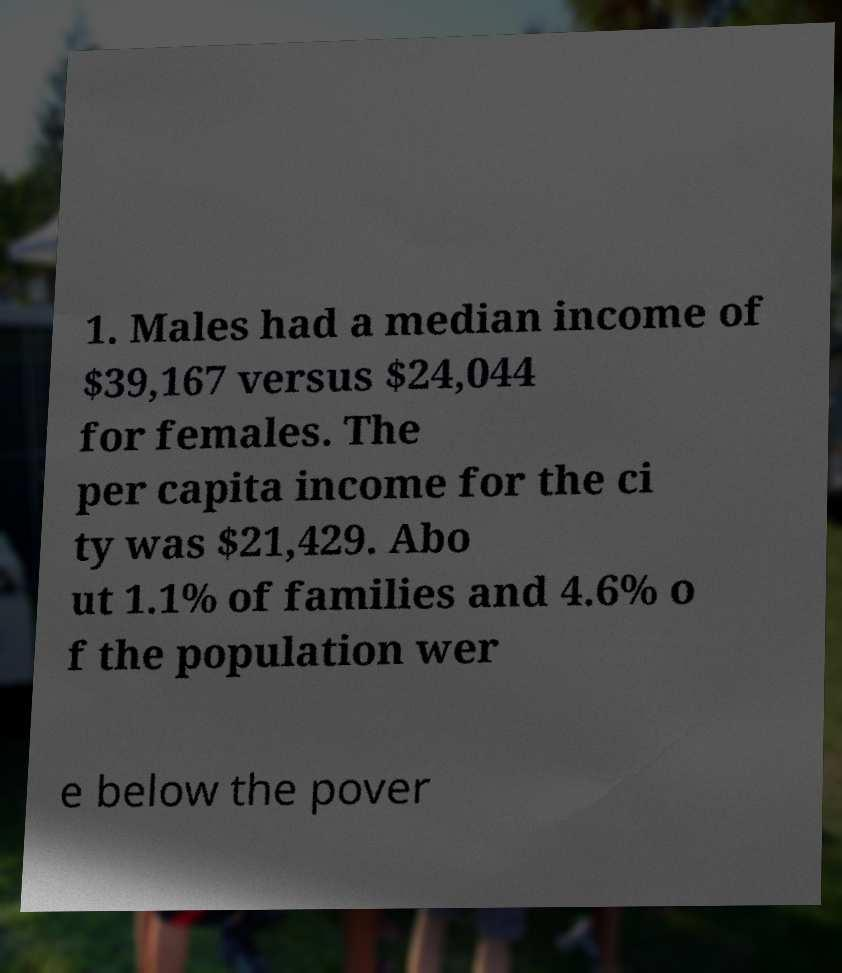For documentation purposes, I need the text within this image transcribed. Could you provide that? 1. Males had a median income of $39,167 versus $24,044 for females. The per capita income for the ci ty was $21,429. Abo ut 1.1% of families and 4.6% o f the population wer e below the pover 